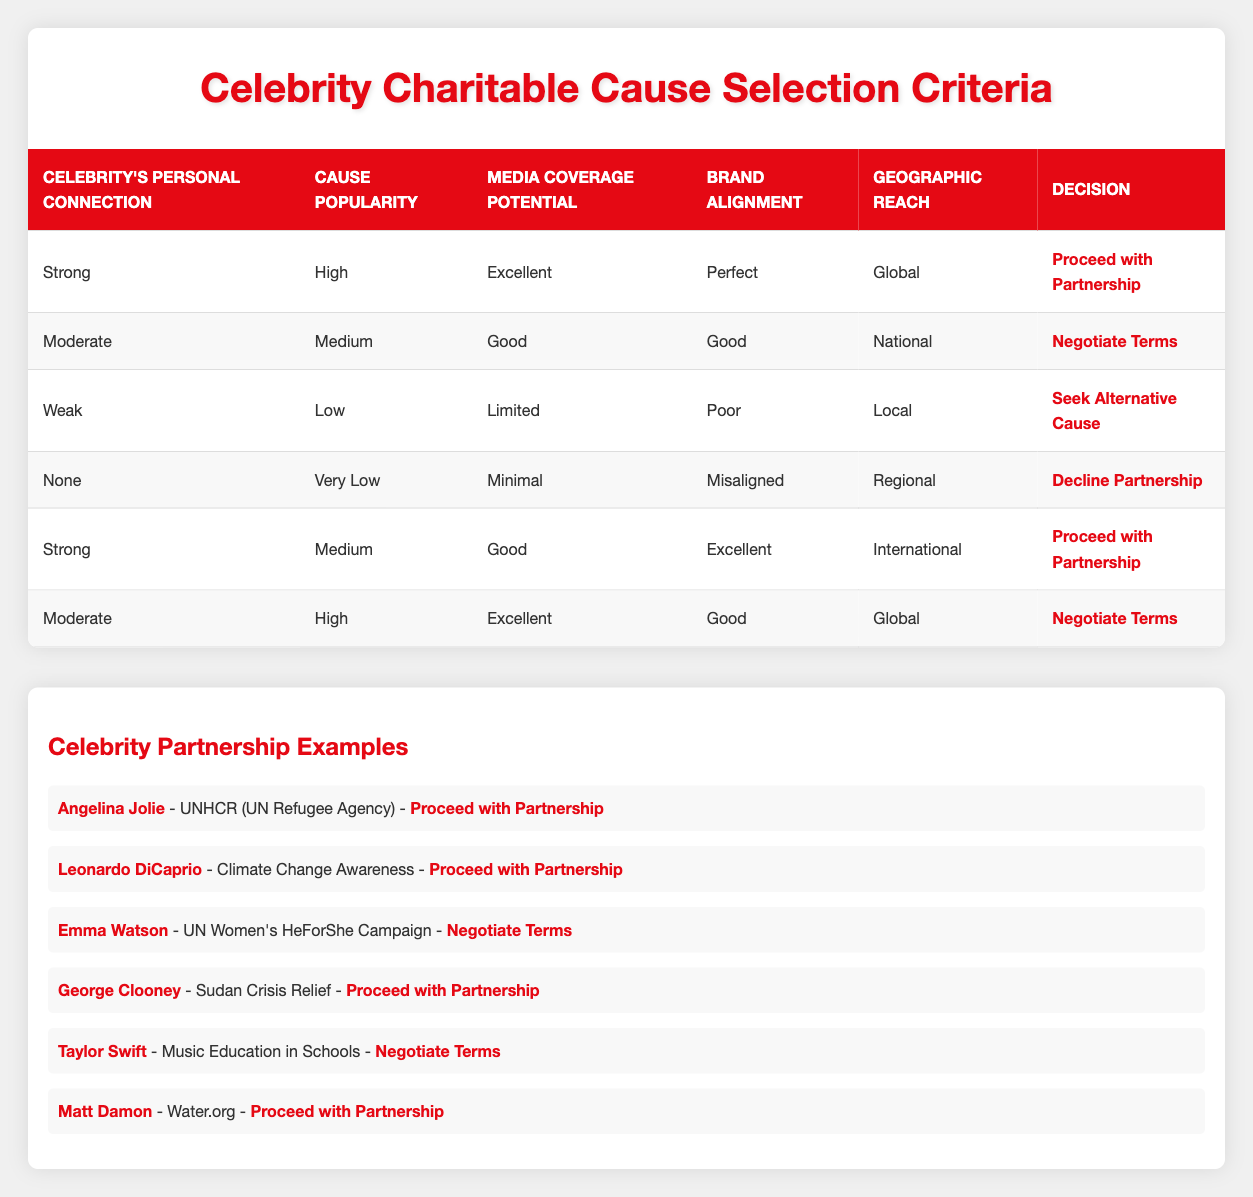What decision is made for a cause with a strong personal connection, high popularity, excellent media coverage potential, perfect brand alignment, and global reach? The table indicates that such a combination corresponds to the first rule, which states "Proceed with Partnership" as the decision.
Answer: Proceed with Partnership How many total criteria are listed in the table? The conditions provided include five criteria: Celebrity's Personal Connection, Cause Popularity, Media Coverage Potential, Brand Alignment, and Geographic Reach, making a total of five criteria.
Answer: 5 Is it true that a weak personal connection and low cause popularity lead to seeking an alternative cause? According to the third rule in the table, "Weak" personal connection and "Low" cause popularity lead to the decision "Seek Alternative Cause," making this statement true.
Answer: Yes What is the decision if a celebrity has a strong personal connection, medium cause popularity, good media coverage potential, excellent brand alignment, and international reach? The fourth rule indicates that this combination allows for the decision "Proceed with Partnership."
Answer: Proceed with Partnership If the cause has very low popularity and a misaligned brand, what is the decision? The fourth row in the table specifies that with "Very Low" cause popularity and "Misaligned" brand alignment, the decision is "Decline Partnership."
Answer: Decline Partnership What are the decisions for all combinations with moderate personal connection? Upon reviewing the table, there are two cases with "Moderate" personal connection: one leads to "Negotiate Terms" (medium popularity, good media coverage) and the other also leads to "Negotiate Terms" (high popularity, excellent media coverage).
Answer: Negotiate Terms How many decisions lead to declining partnerships based on the criteria provided? Reviewing the table, only one scenario shows "Decline Partnership" which corresponds to having no personal connection, very low popularity, minimal media coverage, misaligned brand alignment, and regional reach. Hence, the total is one.
Answer: 1 If the media coverage potential is excellent, does it guarantee a partnership will proceed? Examining the table, although excellent media coverage potential appears, it is not a guarantee on its own. This can be combined with personal connection and cause popularity to determine the final decision. For example, strong connection and high popularity lead to proceeding with a partnership, but moderate connection with medium popularity leads to negotiating terms. Thus, it does not guarantee proceeding alone.
Answer: No What decision does a celebrity make if they have a strong personal connection and good brand alignment while the cause has limited media coverage and local geographic reach? Analyzing the table, this situation doesn’t apply to any of the listed rules, but similar conditions with strong personal connection and good brand alignment typically yield "Proceed with Partnership." However, since media coverage is limited and geographic reach is local, it suggests a weaker case, leading to "Seek Alternative Cause."
Answer: Seek Alternative Cause 